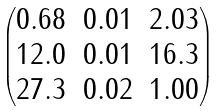<formula> <loc_0><loc_0><loc_500><loc_500>\begin{pmatrix} 0 . 6 8 & 0 . 0 1 & 2 . 0 3 \\ 1 2 . 0 & 0 . 0 1 & 1 6 . 3 \\ 2 7 . 3 & 0 . 0 2 & 1 . 0 0 \end{pmatrix}</formula> 